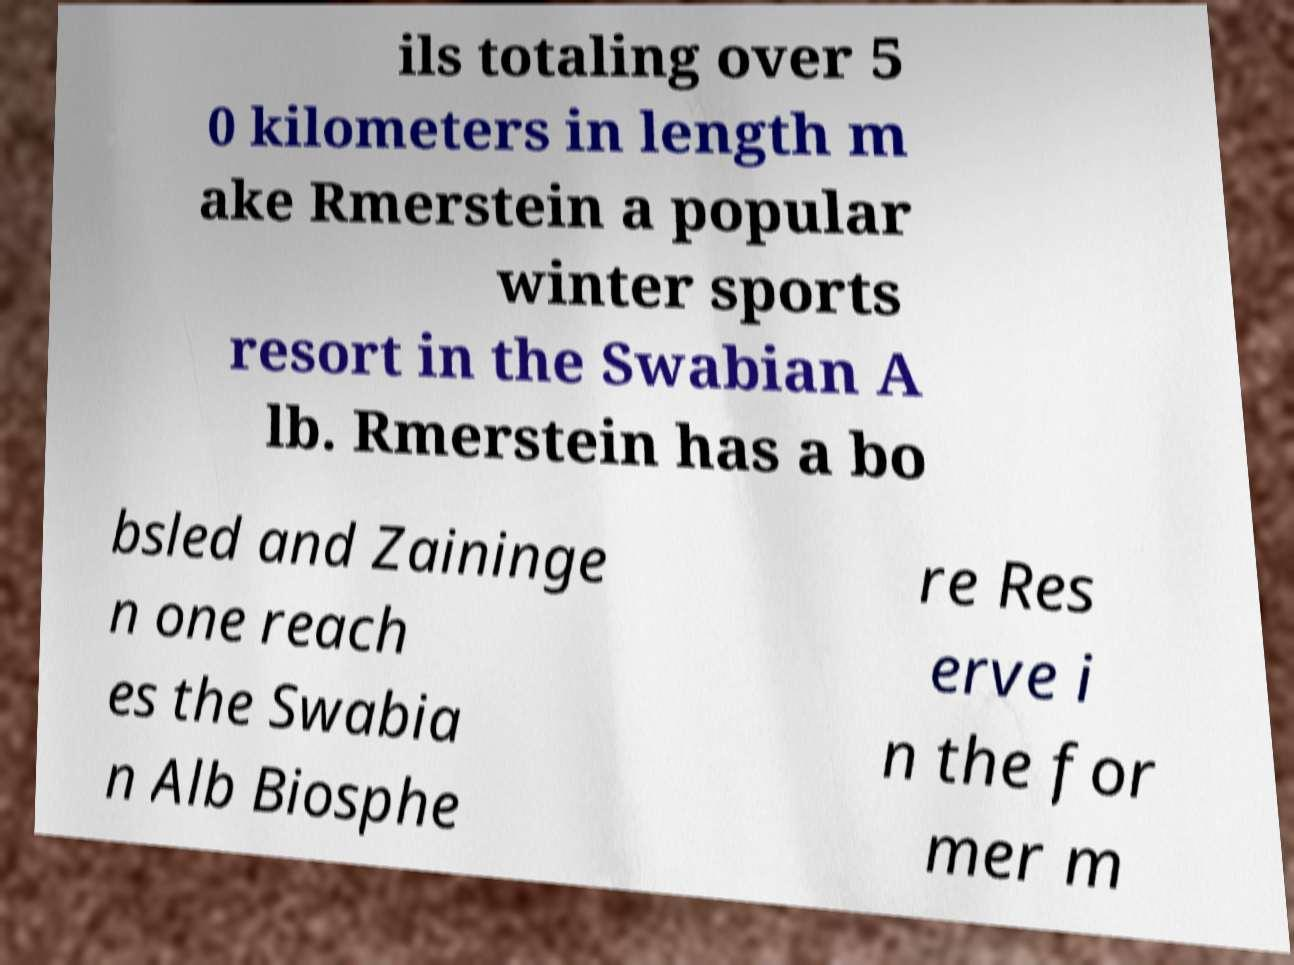Could you extract and type out the text from this image? ils totaling over 5 0 kilometers in length m ake Rmerstein a popular winter sports resort in the Swabian A lb. Rmerstein has a bo bsled and Zaininge n one reach es the Swabia n Alb Biosphe re Res erve i n the for mer m 